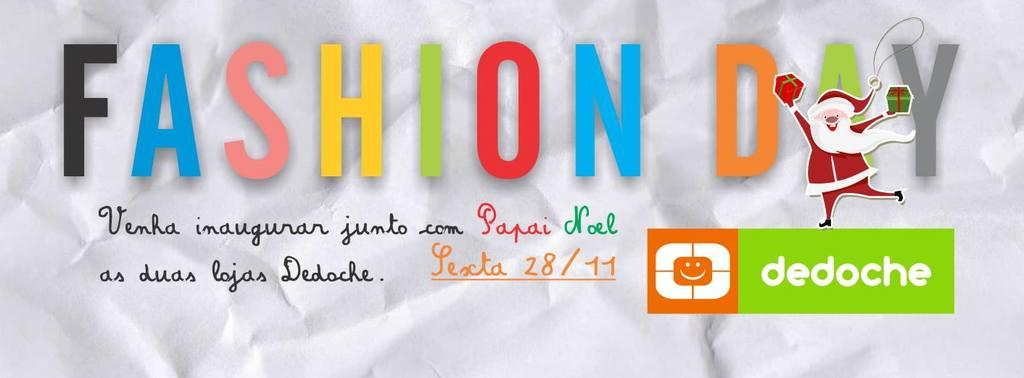What is present in the image that contains written information? There is text in the image. What type of symbol or design is present in the image? There is a logo in the image. What is the person in the image doing? The person is holding gifts in the image. On what surface is the image displayed? The image appears to be on a board. What type of button can be seen on the person's shirt in the image? There is no button visible on the person's shirt in the image. What type of jewel is present in the image? There is no jewel present in the image. 